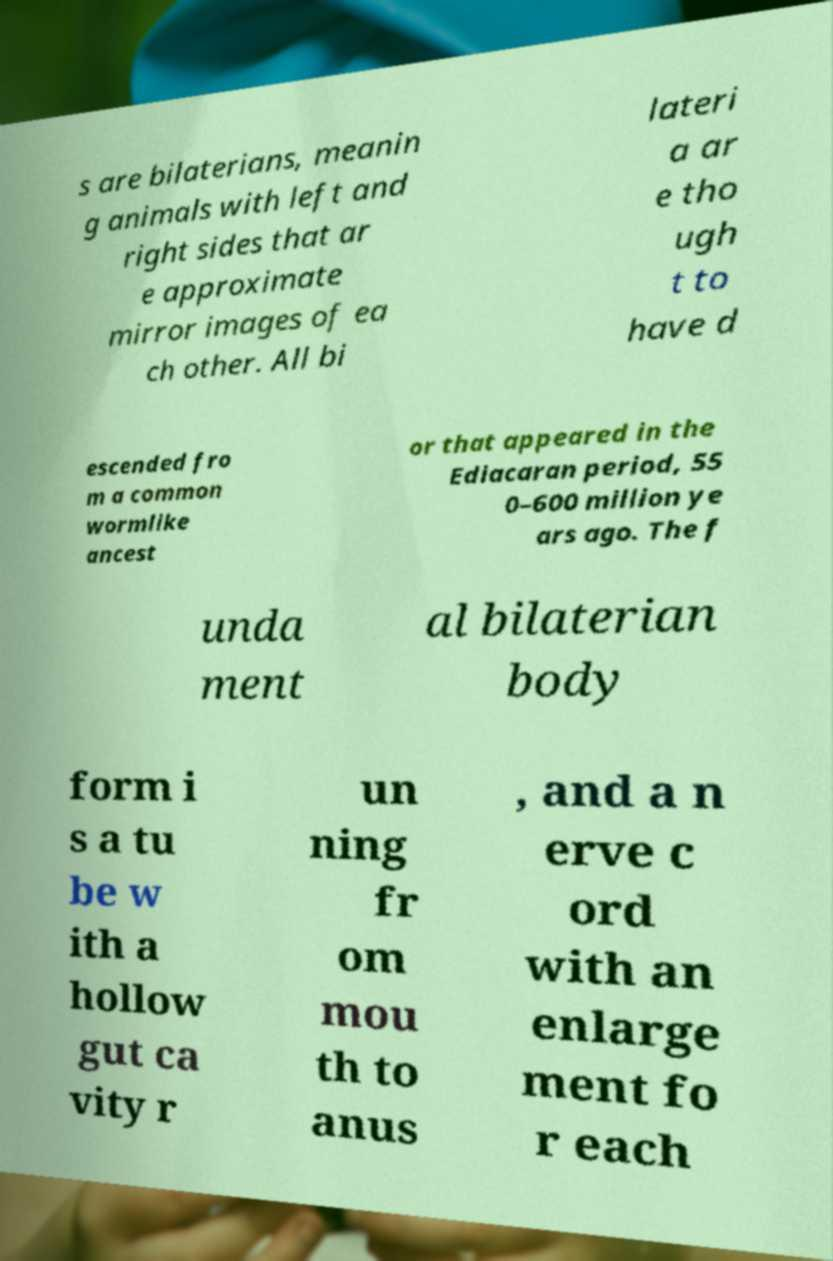Please identify and transcribe the text found in this image. s are bilaterians, meanin g animals with left and right sides that ar e approximate mirror images of ea ch other. All bi lateri a ar e tho ugh t to have d escended fro m a common wormlike ancest or that appeared in the Ediacaran period, 55 0–600 million ye ars ago. The f unda ment al bilaterian body form i s a tu be w ith a hollow gut ca vity r un ning fr om mou th to anus , and a n erve c ord with an enlarge ment fo r each 